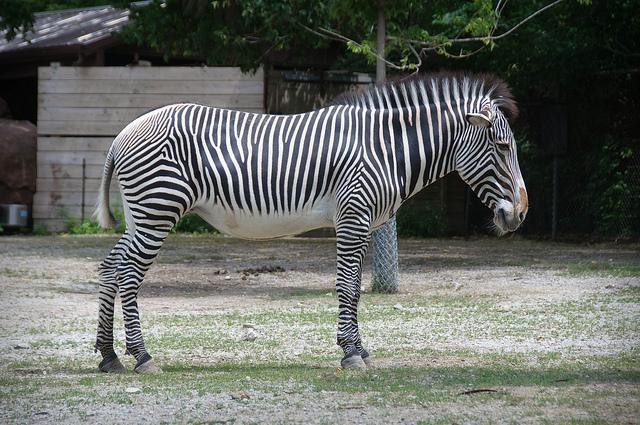Does the zebras hair looked striped?
Short answer required. Yes. Is the zebra charging?
Keep it brief. No. Is the zebra standing in the grass?
Concise answer only. Yes. What is the wall made of?
Give a very brief answer. Wood. What color is the zebra's mohawk?
Keep it brief. Black and white. Is this a female or male zebra?
Short answer required. Female. How many zebras are there?
Concise answer only. 1. Is there a log on the ground?
Write a very short answer. No. What is the zebra doing?
Concise answer only. Standing. What color is the zebra's belly?
Quick response, please. White. Is the zebra eating?
Answer briefly. No. What is the object behind the zebra's feet?
Give a very brief answer. Grass. 